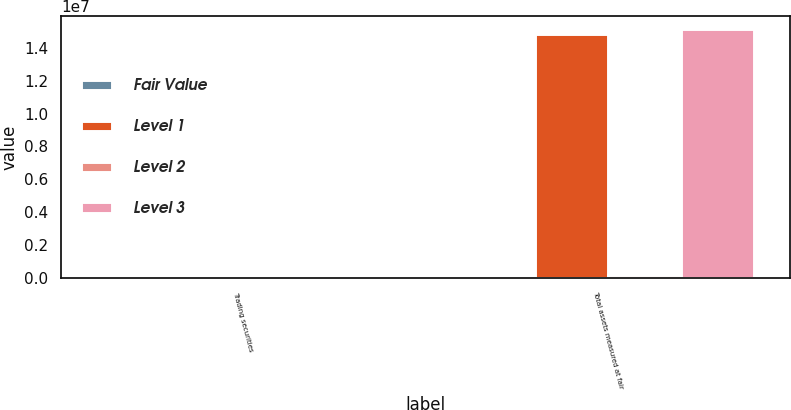Convert chart. <chart><loc_0><loc_0><loc_500><loc_500><stacked_bar_chart><ecel><fcel>Trading securities<fcel>Total assets measured at fair<nl><fcel>Fair Value<fcel>55630<fcel>93630<nl><fcel>Level 1<fcel>5913<fcel>1.48653e+07<nl><fcel>Level 2<fcel>630<fcel>195850<nl><fcel>Level 3<fcel>62173<fcel>1.51548e+07<nl></chart> 